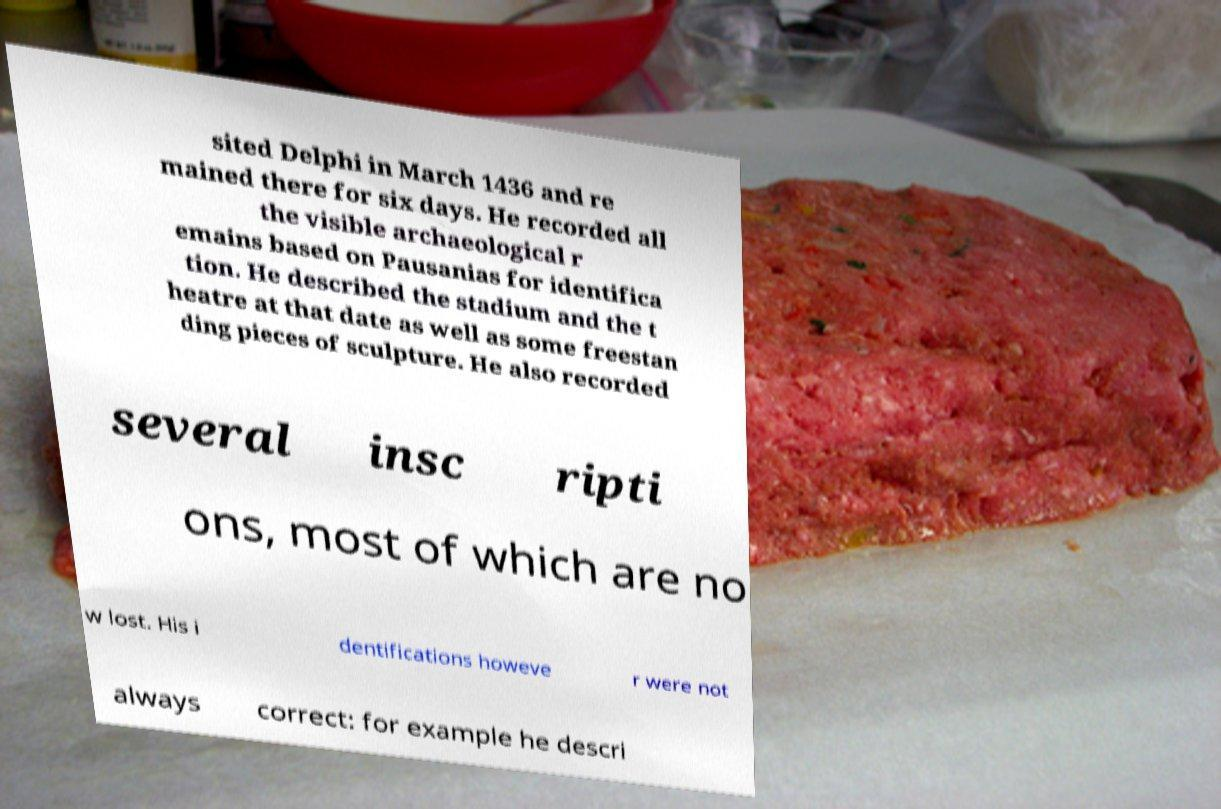I need the written content from this picture converted into text. Can you do that? sited Delphi in March 1436 and re mained there for six days. He recorded all the visible archaeological r emains based on Pausanias for identifica tion. He described the stadium and the t heatre at that date as well as some freestan ding pieces of sculpture. He also recorded several insc ripti ons, most of which are no w lost. His i dentifications howeve r were not always correct: for example he descri 